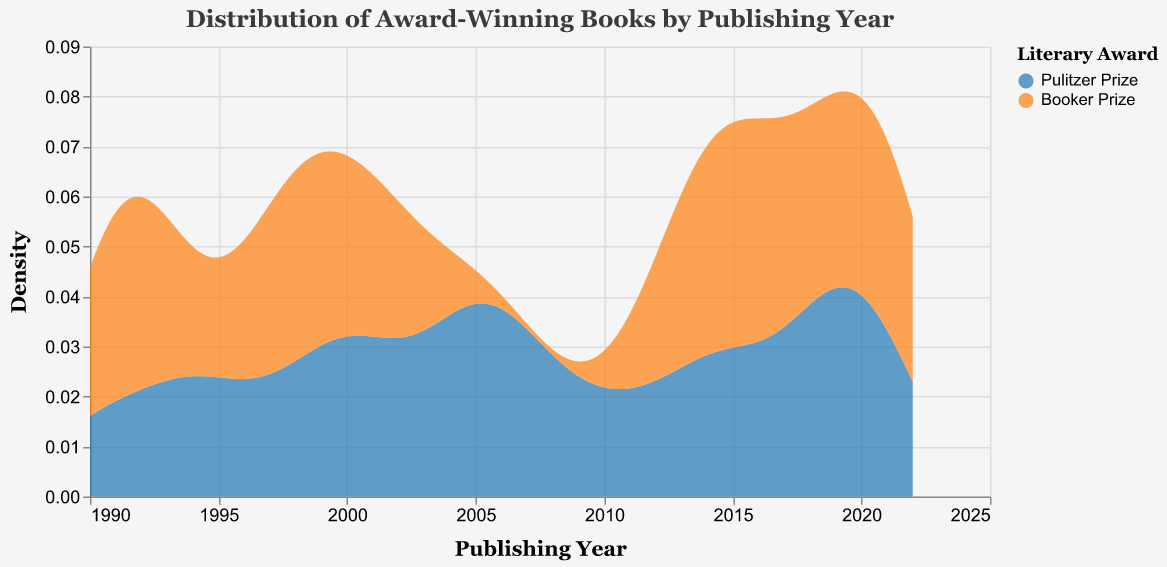What is the title of the figure? The title of the figure is located at the top, usually larger than other text elements.
Answer: Distribution of Award-Winning Books by Publishing Year What color represents the Pulitzer Prize winners? In the color legend, Pulitzer Prize winners are assigned a color.
Answer: Blue Which award shows a higher density of books in 2000? To find this, look at the density values around the year 2000 and compare between the two awards represented by different colors. The area with a higher density will be taller.
Answer: Pulitzer Prize Between 1990 and 1995, which award has more books? Observe the density distribution from 1990 to 1995 for both awards. The one with more area under the curve in the specified range has more books.
Answer: Pulitzer Prize How many publishing peaks do Booker Prize winners show in the figure? Count the distinct peaks (high points) in the density distribution for the Booker Prize.
Answer: 3 In which year range do we see the highest density of Pulitzer Prize winners? Look for the peak in the density curve for the Pulitzer Prize and note the years around this peak.
Answer: 2015-2020 Does the figure indicate any Booker Prize winning books published after 2020? Check the distribution for the Booker Prize and see if there’s any density extending beyond the year 2020.
Answer: No Which award has a wider spread of book publishing years? Compare the width of the distributions for both awards. The one with a broader spread or distribution range is the answer.
Answer: Pulitzer Prize Are there more Pulitzer Prize-winning books published in the 1990s or 2000s? Compare the density areas for the Pulitzer Prize winners in the two decades by aggregating the densities.
Answer: 2000s 